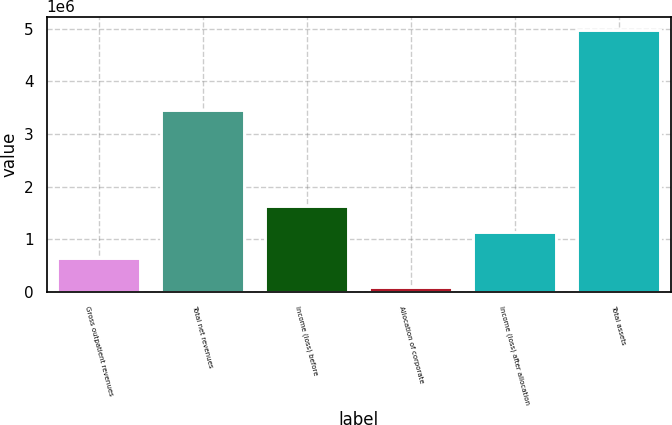<chart> <loc_0><loc_0><loc_500><loc_500><bar_chart><fcel>Gross outpatient revenues<fcel>Total net revenues<fcel>Income (loss) before<fcel>Allocation of corporate<fcel>Income (loss) after allocation<fcel>Total assets<nl><fcel>646177<fcel>3.46014e+06<fcel>1.62525e+06<fcel>84597<fcel>1.13571e+06<fcel>4.97996e+06<nl></chart> 